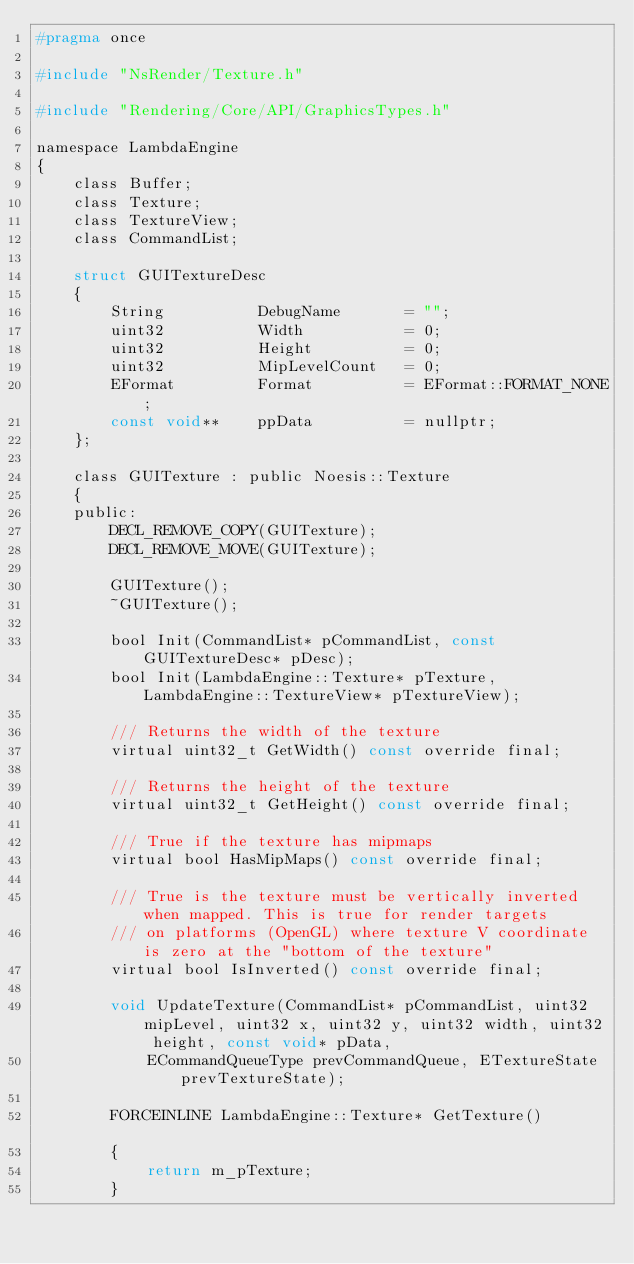<code> <loc_0><loc_0><loc_500><loc_500><_C_>#pragma once

#include "NsRender/Texture.h"

#include "Rendering/Core/API/GraphicsTypes.h"

namespace LambdaEngine
{
	class Buffer;
	class Texture;
	class TextureView;
	class CommandList;

	struct GUITextureDesc
	{
		String			DebugName		= "";
		uint32			Width			= 0;
		uint32			Height			= 0;
		uint32			MipLevelCount	= 0;
		EFormat			Format			= EFormat::FORMAT_NONE;
		const void**	ppData			= nullptr;
	};

	class GUITexture : public Noesis::Texture
	{
	public:
		DECL_REMOVE_COPY(GUITexture);
		DECL_REMOVE_MOVE(GUITexture);

		GUITexture();
		~GUITexture();

		bool Init(CommandList* pCommandList, const GUITextureDesc* pDesc);
		bool Init(LambdaEngine::Texture* pTexture, LambdaEngine::TextureView* pTextureView);

		/// Returns the width of the texture
		virtual uint32_t GetWidth() const override final;

		/// Returns the height of the texture
		virtual uint32_t GetHeight() const override final;

		/// True if the texture has mipmaps
		virtual bool HasMipMaps() const override final;

		/// True is the texture must be vertically inverted when mapped. This is true for render targets
		/// on platforms (OpenGL) where texture V coordinate is zero at the "bottom of the texture"
		virtual bool IsInverted() const override final;

		void UpdateTexture(CommandList* pCommandList, uint32 mipLevel, uint32 x, uint32 y, uint32 width, uint32 height, const void* pData,
			ECommandQueueType prevCommandQueue, ETextureState prevTextureState);

		FORCEINLINE LambdaEngine::Texture* GetTexture()			
		{ 
			return m_pTexture;
		}
</code> 